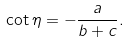Convert formula to latex. <formula><loc_0><loc_0><loc_500><loc_500>\cot \eta = - \frac { a } { b + c } .</formula> 